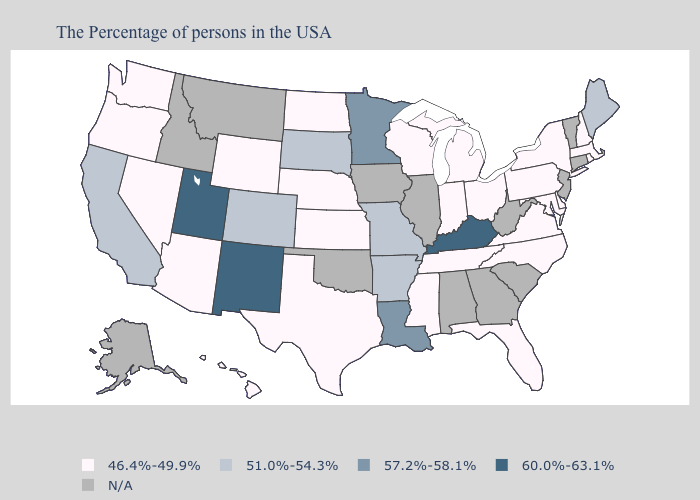Does the first symbol in the legend represent the smallest category?
Be succinct. Yes. Among the states that border South Dakota , which have the lowest value?
Be succinct. Nebraska, North Dakota, Wyoming. What is the highest value in the South ?
Write a very short answer. 60.0%-63.1%. What is the highest value in the USA?
Write a very short answer. 60.0%-63.1%. What is the highest value in states that border Vermont?
Write a very short answer. 46.4%-49.9%. What is the lowest value in the West?
Write a very short answer. 46.4%-49.9%. Does Pennsylvania have the lowest value in the Northeast?
Answer briefly. Yes. Which states hav the highest value in the MidWest?
Answer briefly. Minnesota. What is the value of Arkansas?
Quick response, please. 51.0%-54.3%. Which states have the lowest value in the USA?
Quick response, please. Massachusetts, Rhode Island, New Hampshire, New York, Delaware, Maryland, Pennsylvania, Virginia, North Carolina, Ohio, Florida, Michigan, Indiana, Tennessee, Wisconsin, Mississippi, Kansas, Nebraska, Texas, North Dakota, Wyoming, Arizona, Nevada, Washington, Oregon, Hawaii. Does Pennsylvania have the lowest value in the Northeast?
Quick response, please. Yes. Does Arkansas have the lowest value in the USA?
Concise answer only. No. Name the states that have a value in the range 57.2%-58.1%?
Be succinct. Louisiana, Minnesota. What is the value of Massachusetts?
Quick response, please. 46.4%-49.9%. 